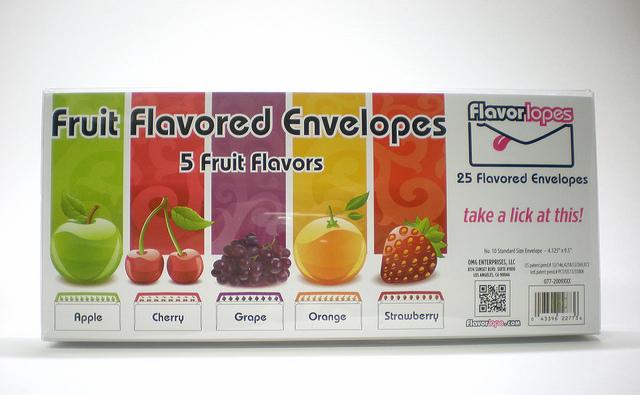Is there a barcode in the picture?
Answer briefly. Yes. How many flavors are available?
Answer briefly. 5. Is this an advertisement?
Short answer required. Yes. 